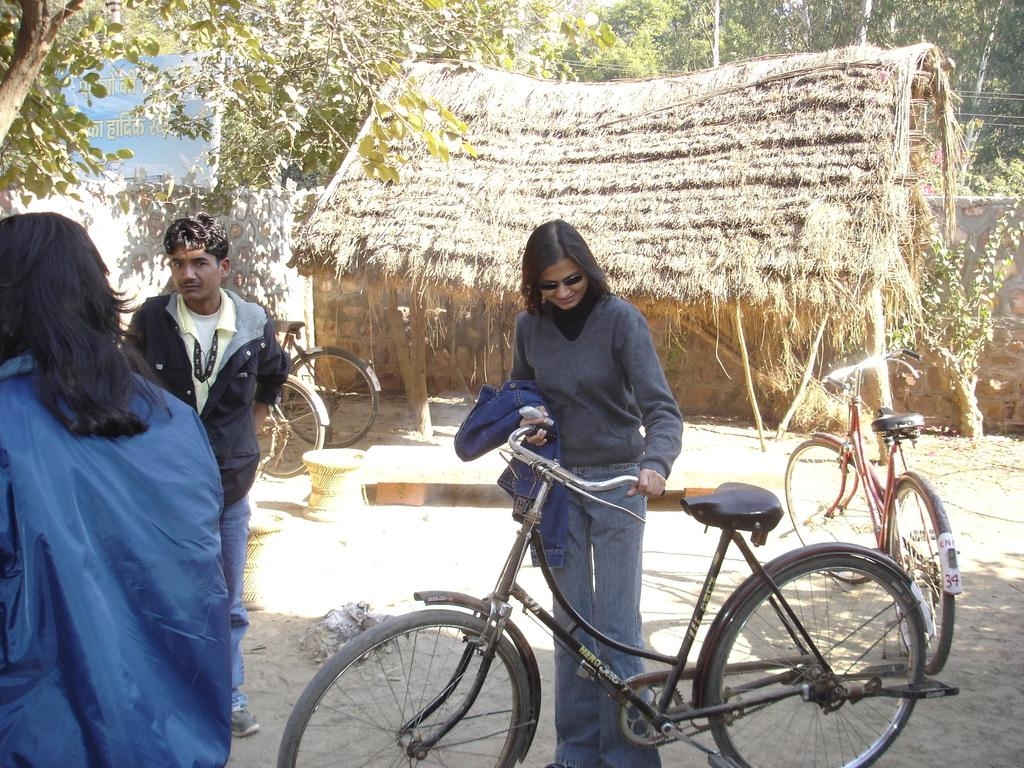What type of vehicles are in the image? There are bicycles in the image. How many people are in the image? There are three persons in the image. What is one person doing with a bicycle? One person is holding an object and a bicycle. What structures can be seen in the image? There is a wall and a hut in the image. What type of natural elements are in the image? There are trees in the image. What part of the environment is visible in the image? The sky is visible in the image. What type of stitch is being used to repair the bicycle tire in the image? There is no bicycle tire repair or stitching visible in the image. What type of paste is being used to hold the hut together in the image? There is no visible construction or paste being used to hold the hut together in the image. 